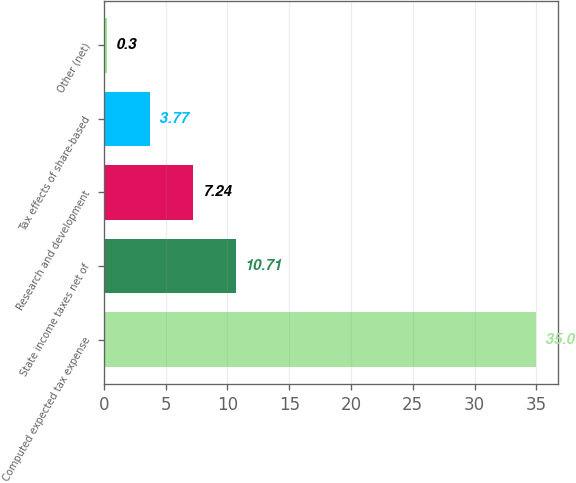Convert chart. <chart><loc_0><loc_0><loc_500><loc_500><bar_chart><fcel>Computed expected tax expense<fcel>State income taxes net of<fcel>Research and development<fcel>Tax effects of share-based<fcel>Other (net)<nl><fcel>35<fcel>10.71<fcel>7.24<fcel>3.77<fcel>0.3<nl></chart> 